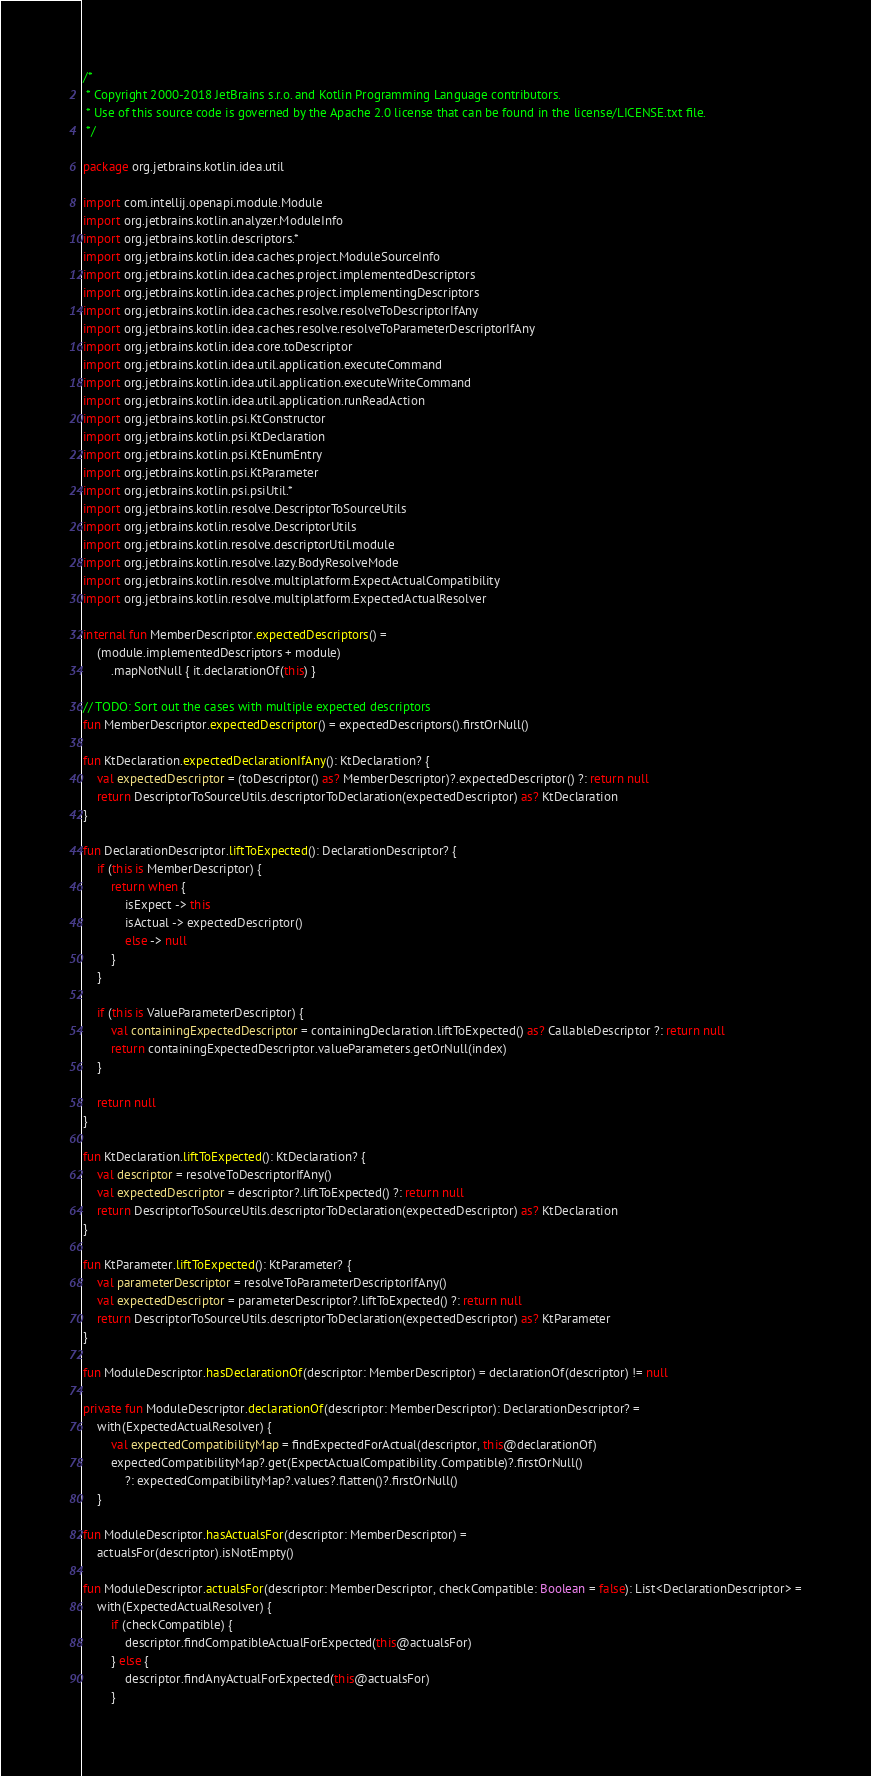Convert code to text. <code><loc_0><loc_0><loc_500><loc_500><_Kotlin_>/*
 * Copyright 2000-2018 JetBrains s.r.o. and Kotlin Programming Language contributors.
 * Use of this source code is governed by the Apache 2.0 license that can be found in the license/LICENSE.txt file.
 */

package org.jetbrains.kotlin.idea.util

import com.intellij.openapi.module.Module
import org.jetbrains.kotlin.analyzer.ModuleInfo
import org.jetbrains.kotlin.descriptors.*
import org.jetbrains.kotlin.idea.caches.project.ModuleSourceInfo
import org.jetbrains.kotlin.idea.caches.project.implementedDescriptors
import org.jetbrains.kotlin.idea.caches.project.implementingDescriptors
import org.jetbrains.kotlin.idea.caches.resolve.resolveToDescriptorIfAny
import org.jetbrains.kotlin.idea.caches.resolve.resolveToParameterDescriptorIfAny
import org.jetbrains.kotlin.idea.core.toDescriptor
import org.jetbrains.kotlin.idea.util.application.executeCommand
import org.jetbrains.kotlin.idea.util.application.executeWriteCommand
import org.jetbrains.kotlin.idea.util.application.runReadAction
import org.jetbrains.kotlin.psi.KtConstructor
import org.jetbrains.kotlin.psi.KtDeclaration
import org.jetbrains.kotlin.psi.KtEnumEntry
import org.jetbrains.kotlin.psi.KtParameter
import org.jetbrains.kotlin.psi.psiUtil.*
import org.jetbrains.kotlin.resolve.DescriptorToSourceUtils
import org.jetbrains.kotlin.resolve.DescriptorUtils
import org.jetbrains.kotlin.resolve.descriptorUtil.module
import org.jetbrains.kotlin.resolve.lazy.BodyResolveMode
import org.jetbrains.kotlin.resolve.multiplatform.ExpectActualCompatibility
import org.jetbrains.kotlin.resolve.multiplatform.ExpectedActualResolver

internal fun MemberDescriptor.expectedDescriptors() =
    (module.implementedDescriptors + module)
        .mapNotNull { it.declarationOf(this) }

// TODO: Sort out the cases with multiple expected descriptors
fun MemberDescriptor.expectedDescriptor() = expectedDescriptors().firstOrNull()

fun KtDeclaration.expectedDeclarationIfAny(): KtDeclaration? {
    val expectedDescriptor = (toDescriptor() as? MemberDescriptor)?.expectedDescriptor() ?: return null
    return DescriptorToSourceUtils.descriptorToDeclaration(expectedDescriptor) as? KtDeclaration
}

fun DeclarationDescriptor.liftToExpected(): DeclarationDescriptor? {
    if (this is MemberDescriptor) {
        return when {
            isExpect -> this
            isActual -> expectedDescriptor()
            else -> null
        }
    }

    if (this is ValueParameterDescriptor) {
        val containingExpectedDescriptor = containingDeclaration.liftToExpected() as? CallableDescriptor ?: return null
        return containingExpectedDescriptor.valueParameters.getOrNull(index)
    }

    return null
}

fun KtDeclaration.liftToExpected(): KtDeclaration? {
    val descriptor = resolveToDescriptorIfAny()
    val expectedDescriptor = descriptor?.liftToExpected() ?: return null
    return DescriptorToSourceUtils.descriptorToDeclaration(expectedDescriptor) as? KtDeclaration
}

fun KtParameter.liftToExpected(): KtParameter? {
    val parameterDescriptor = resolveToParameterDescriptorIfAny()
    val expectedDescriptor = parameterDescriptor?.liftToExpected() ?: return null
    return DescriptorToSourceUtils.descriptorToDeclaration(expectedDescriptor) as? KtParameter
}

fun ModuleDescriptor.hasDeclarationOf(descriptor: MemberDescriptor) = declarationOf(descriptor) != null

private fun ModuleDescriptor.declarationOf(descriptor: MemberDescriptor): DeclarationDescriptor? =
    with(ExpectedActualResolver) {
        val expectedCompatibilityMap = findExpectedForActual(descriptor, this@declarationOf)
        expectedCompatibilityMap?.get(ExpectActualCompatibility.Compatible)?.firstOrNull()
            ?: expectedCompatibilityMap?.values?.flatten()?.firstOrNull()
    }

fun ModuleDescriptor.hasActualsFor(descriptor: MemberDescriptor) =
    actualsFor(descriptor).isNotEmpty()

fun ModuleDescriptor.actualsFor(descriptor: MemberDescriptor, checkCompatible: Boolean = false): List<DeclarationDescriptor> =
    with(ExpectedActualResolver) {
        if (checkCompatible) {
            descriptor.findCompatibleActualForExpected(this@actualsFor)
        } else {
            descriptor.findAnyActualForExpected(this@actualsFor)
        }</code> 